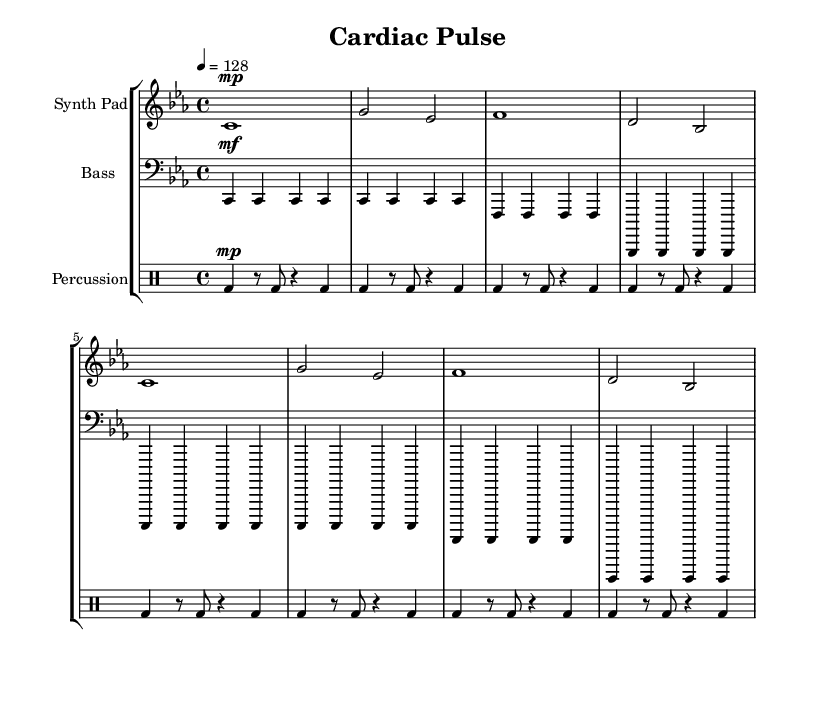What is the key signature of this music? The key signature is C minor, which has three flats: B flat, E flat, and A flat. You can identify the key signature by looking at the specific symbols at the beginning of the staff.
Answer: C minor What is the time signature of this piece? The time signature is 4/4, which means there are four beats in each measure and the quarter note receives one beat. This is indicated at the beginning of the score next to the key signature.
Answer: 4/4 What is the tempo marking for this piece? The tempo marking is 128 beats per minute, indicated by the notation in the tempo section. This tells the performer how fast to play the piece.
Answer: 128 What is the general texture of the music? The music features a layered texture with three parts: synth pad, bass, and percussion, showing a traditional house setup. The different instruments contribute to a rich sound, common in ambient house tracks.
Answer: Layered How many measures are in the synth pad part? The synth pad part consists of six measures, which can be counted by tallying the individual bars found within the staff indicated for the synth pad.
Answer: Six Which instrument plays the bass line? The instrument that plays the bass line is the bass, indicated in the score. It provides a foundational harmonic structure typical for house music.
Answer: Bass How often does the kick drum appear in the percussion section? The kick drum appears consistently at the beginning of each measure, maintaining a steady pulse, which is a characteristic rhythmic element in house music.
Answer: Every measure 